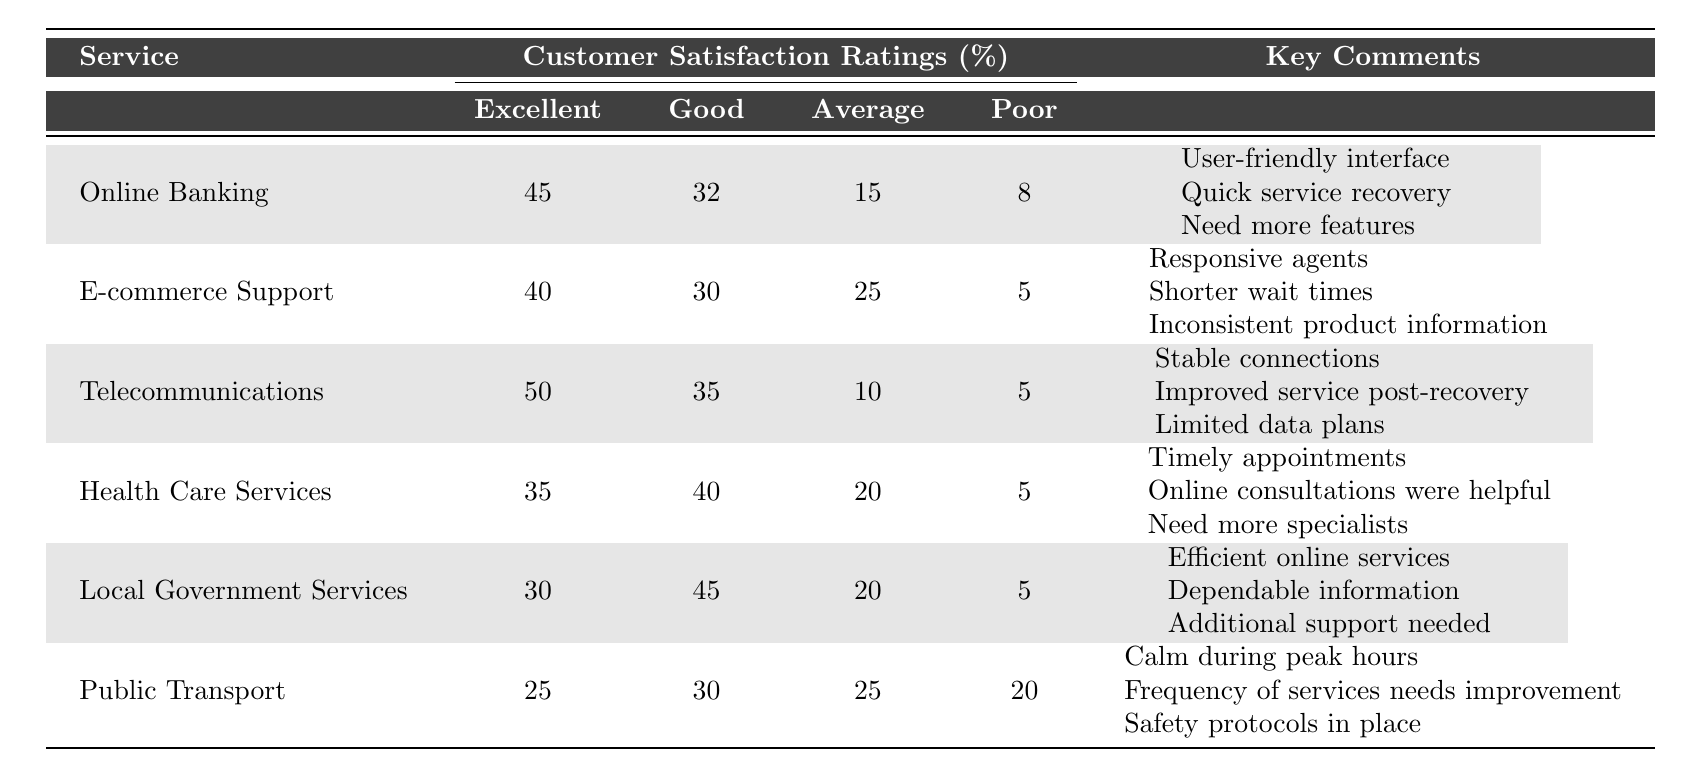What percentage of customers rated Online Banking as Excellent? The table shows that 45 customers rated Online Banking as Excellent, which is presented under the Excellent column.
Answer: 45% What is the total percentage of customers who rated E-commerce Support as Average or Poor? Adding the percentages for Average (25) and Poor (5) for E-commerce Support gives 25 + 5 = 30%.
Answer: 30% Which service received the highest percentage of Excellent ratings? By comparing the Excellent ratings for each service, Telecommunications has the highest at 50%.
Answer: Telecommunications Did more customers rate Health Care Services as Good than Excellent? Health Care Services received 40% as Good and 35% as Excellent. Since 40 is greater than 35, the answer is yes.
Answer: Yes What is the average percentage of Excellent ratings across all services? To find the average, add all Excellent ratings (45 + 40 + 50 + 35 + 30 + 25 = 225) and divide by 6, giving 225 / 6 = 37.5%.
Answer: 37.5% Which service had the lowest percentage of customer satisfaction ratings classified as Poor? Public Transport has the lowest percentage under Poor with 20%.
Answer: Public Transport Could we conclude that Local Government Services had more positive ratings than Public Transport when considering both Excellent and Good categories? Adding Excellent (30) and Good (45) for Local Government Services gives 75%, while Public Transport's Excellent (25) and Good (30) give 55%. Since 75% > 55%, it is true.
Answer: Yes What percentage of customers rated Public Transport as Average? Public Transport has 25% of responses categorized as Average as shown in the Average column.
Answer: 25% How many services received more than 40% for Good ratings? The services with Good ratings over 40% are Telecommunications (35%), Health Care Services (40%), and Local Government Services (45%). Only Local Government Services is above 40%.
Answer: 1 service What is the difference in Excellent ratings between Telecommunications and E-commerce Support? Telecommunications has 50% for Excellent while E-commerce Support has 40%. The difference is 50 - 40 = 10%.
Answer: 10% 